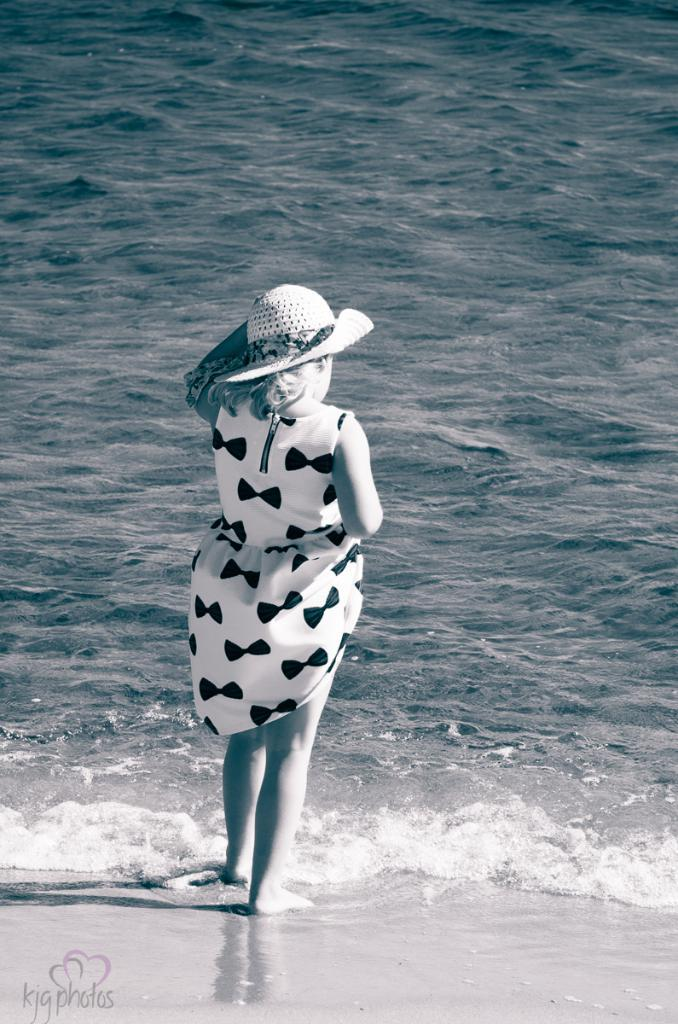Who is present in the image? There is a girl in the image. What is the girl wearing on her head? The girl is wearing a hat. Where is the girl standing in the image? The girl is standing on a sea shore. What can be seen in the background of the image? There is water visible in the image. Is there any additional information about the image itself? Yes, there is a watermark in the left bottom corner of the image. Can you see the girl's fang in the image? There is no fang visible in the image, as the girl is not an animal with fangs. 